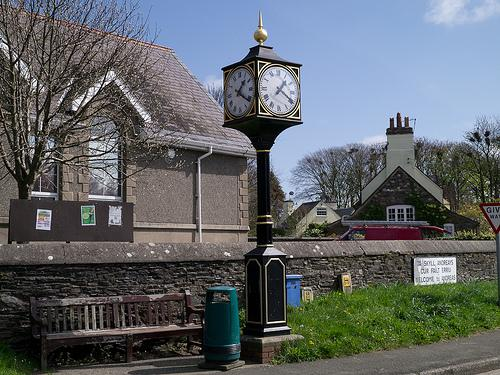For a multi-choice VQA task, create a question about a specific object in the image and provide the correct answer. Green Describe the features of the clock face found in the image. The clock face is black and white, it has roman numerals and is found on a box. Identify the colors of the primary objects in the image and describe their surroundings. The image contains a black and white clock on a box with roman numerals, a green trash can near a brown bench, a blue box in some grass, and white clouds in the blue sky. Talk about the weather and sky condition depicted in the image. The image shows a clear blue sky with white clouds scattered throughout. What type of numeral is present on the clocks in the image? Roman numerals are present on the clocks in the image. 